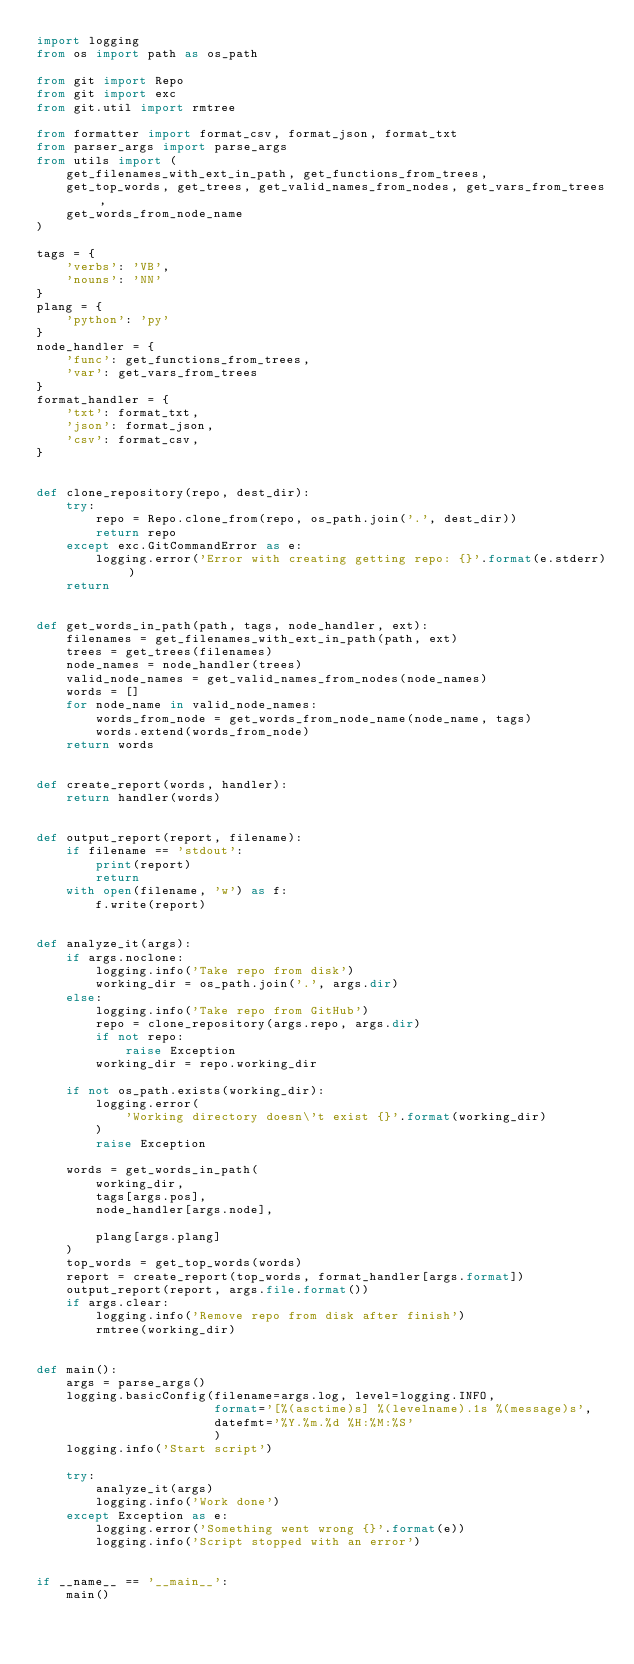Convert code to text. <code><loc_0><loc_0><loc_500><loc_500><_Python_>import logging
from os import path as os_path

from git import Repo
from git import exc
from git.util import rmtree

from formatter import format_csv, format_json, format_txt
from parser_args import parse_args
from utils import (
    get_filenames_with_ext_in_path, get_functions_from_trees,
    get_top_words, get_trees, get_valid_names_from_nodes, get_vars_from_trees,
    get_words_from_node_name
)

tags = {
    'verbs': 'VB',
    'nouns': 'NN'
}
plang = {
    'python': 'py'
}
node_handler = {
    'func': get_functions_from_trees,
    'var': get_vars_from_trees
}
format_handler = {
    'txt': format_txt,
    'json': format_json,
    'csv': format_csv,
}


def clone_repository(repo, dest_dir):
    try:
        repo = Repo.clone_from(repo, os_path.join('.', dest_dir))
        return repo
    except exc.GitCommandError as e:
        logging.error('Error with creating getting repo: {}'.format(e.stderr))
    return


def get_words_in_path(path, tags, node_handler, ext):
    filenames = get_filenames_with_ext_in_path(path, ext)
    trees = get_trees(filenames)
    node_names = node_handler(trees)
    valid_node_names = get_valid_names_from_nodes(node_names)
    words = []
    for node_name in valid_node_names:
        words_from_node = get_words_from_node_name(node_name, tags)
        words.extend(words_from_node)
    return words


def create_report(words, handler):
    return handler(words)


def output_report(report, filename):
    if filename == 'stdout':
        print(report)
        return
    with open(filename, 'w') as f:
        f.write(report)


def analyze_it(args):
    if args.noclone:
        logging.info('Take repo from disk')
        working_dir = os_path.join('.', args.dir)
    else:
        logging.info('Take repo from GitHub')
        repo = clone_repository(args.repo, args.dir)
        if not repo:
            raise Exception
        working_dir = repo.working_dir

    if not os_path.exists(working_dir):
        logging.error(
            'Working directory doesn\'t exist {}'.format(working_dir)
        )
        raise Exception

    words = get_words_in_path(
        working_dir,
        tags[args.pos],
        node_handler[args.node],

        plang[args.plang]
    )
    top_words = get_top_words(words)
    report = create_report(top_words, format_handler[args.format])
    output_report(report, args.file.format())
    if args.clear:
        logging.info('Remove repo from disk after finish')
        rmtree(working_dir)


def main():
    args = parse_args()
    logging.basicConfig(filename=args.log, level=logging.INFO,
                        format='[%(asctime)s] %(levelname).1s %(message)s',
                        datefmt='%Y.%m.%d %H:%M:%S'
                        )
    logging.info('Start script')

    try:
        analyze_it(args)
        logging.info('Work done')
    except Exception as e:
        logging.error('Something went wrong {}'.format(e))
        logging.info('Script stopped with an error')


if __name__ == '__main__':
    main()
</code> 